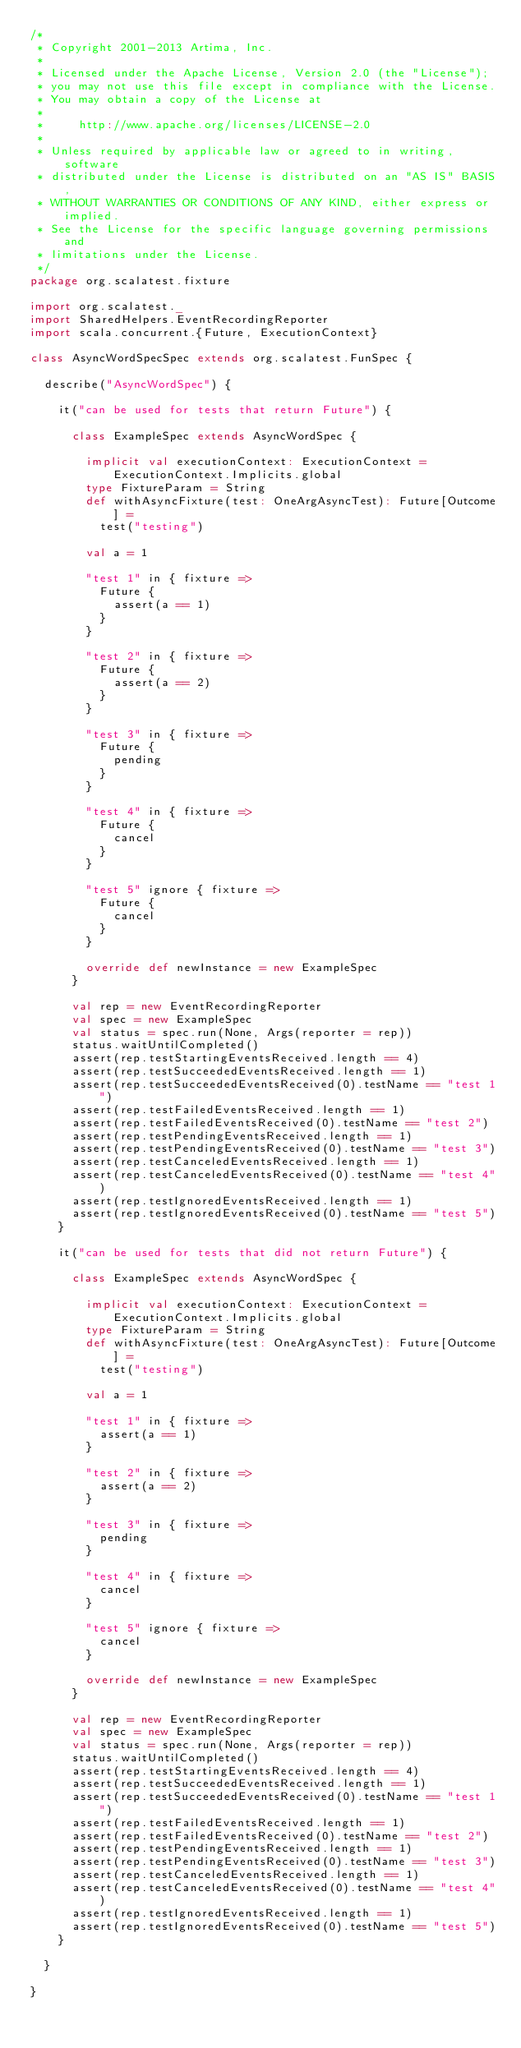<code> <loc_0><loc_0><loc_500><loc_500><_Scala_>/*
 * Copyright 2001-2013 Artima, Inc.
 *
 * Licensed under the Apache License, Version 2.0 (the "License");
 * you may not use this file except in compliance with the License.
 * You may obtain a copy of the License at
 *
 *     http://www.apache.org/licenses/LICENSE-2.0
 *
 * Unless required by applicable law or agreed to in writing, software
 * distributed under the License is distributed on an "AS IS" BASIS,
 * WITHOUT WARRANTIES OR CONDITIONS OF ANY KIND, either express or implied.
 * See the License for the specific language governing permissions and
 * limitations under the License.
 */
package org.scalatest.fixture

import org.scalatest._
import SharedHelpers.EventRecordingReporter
import scala.concurrent.{Future, ExecutionContext}

class AsyncWordSpecSpec extends org.scalatest.FunSpec {

  describe("AsyncWordSpec") {

    it("can be used for tests that return Future") {

      class ExampleSpec extends AsyncWordSpec {

        implicit val executionContext: ExecutionContext = ExecutionContext.Implicits.global
        type FixtureParam = String
        def withAsyncFixture(test: OneArgAsyncTest): Future[Outcome] =
          test("testing")

        val a = 1

        "test 1" in { fixture =>
          Future {
            assert(a == 1)
          }
        }

        "test 2" in { fixture =>
          Future {
            assert(a == 2)
          }
        }

        "test 3" in { fixture =>
          Future {
            pending
          }
        }

        "test 4" in { fixture =>
          Future {
            cancel
          }
        }

        "test 5" ignore { fixture =>
          Future {
            cancel
          }
        }

        override def newInstance = new ExampleSpec
      }

      val rep = new EventRecordingReporter
      val spec = new ExampleSpec
      val status = spec.run(None, Args(reporter = rep))
      status.waitUntilCompleted()
      assert(rep.testStartingEventsReceived.length == 4)
      assert(rep.testSucceededEventsReceived.length == 1)
      assert(rep.testSucceededEventsReceived(0).testName == "test 1")
      assert(rep.testFailedEventsReceived.length == 1)
      assert(rep.testFailedEventsReceived(0).testName == "test 2")
      assert(rep.testPendingEventsReceived.length == 1)
      assert(rep.testPendingEventsReceived(0).testName == "test 3")
      assert(rep.testCanceledEventsReceived.length == 1)
      assert(rep.testCanceledEventsReceived(0).testName == "test 4")
      assert(rep.testIgnoredEventsReceived.length == 1)
      assert(rep.testIgnoredEventsReceived(0).testName == "test 5")
    }

    it("can be used for tests that did not return Future") {

      class ExampleSpec extends AsyncWordSpec {

        implicit val executionContext: ExecutionContext = ExecutionContext.Implicits.global
        type FixtureParam = String
        def withAsyncFixture(test: OneArgAsyncTest): Future[Outcome] =
          test("testing")

        val a = 1

        "test 1" in { fixture =>
          assert(a == 1)
        }

        "test 2" in { fixture =>
          assert(a == 2)
        }

        "test 3" in { fixture =>
          pending
        }

        "test 4" in { fixture =>
          cancel
        }

        "test 5" ignore { fixture =>
          cancel
        }

        override def newInstance = new ExampleSpec
      }

      val rep = new EventRecordingReporter
      val spec = new ExampleSpec
      val status = spec.run(None, Args(reporter = rep))
      status.waitUntilCompleted()
      assert(rep.testStartingEventsReceived.length == 4)
      assert(rep.testSucceededEventsReceived.length == 1)
      assert(rep.testSucceededEventsReceived(0).testName == "test 1")
      assert(rep.testFailedEventsReceived.length == 1)
      assert(rep.testFailedEventsReceived(0).testName == "test 2")
      assert(rep.testPendingEventsReceived.length == 1)
      assert(rep.testPendingEventsReceived(0).testName == "test 3")
      assert(rep.testCanceledEventsReceived.length == 1)
      assert(rep.testCanceledEventsReceived(0).testName == "test 4")
      assert(rep.testIgnoredEventsReceived.length == 1)
      assert(rep.testIgnoredEventsReceived(0).testName == "test 5")
    }

  }

}</code> 